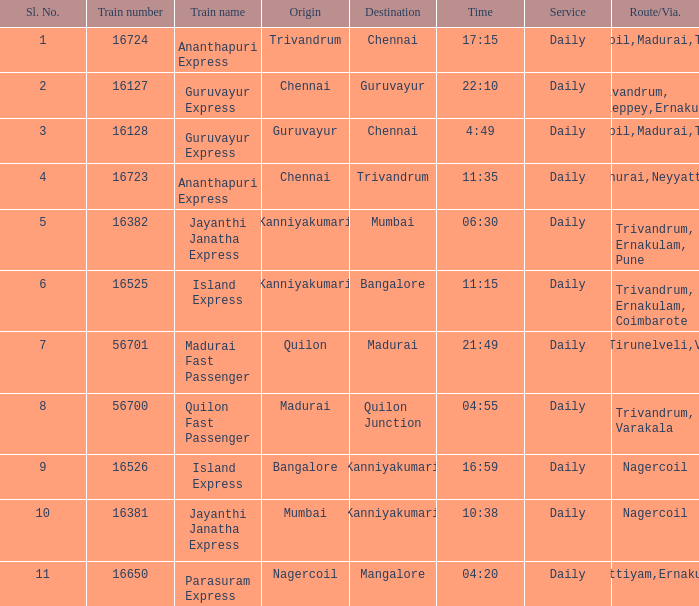What is the origin when the destination is Mumbai? Kanniyakumari. 